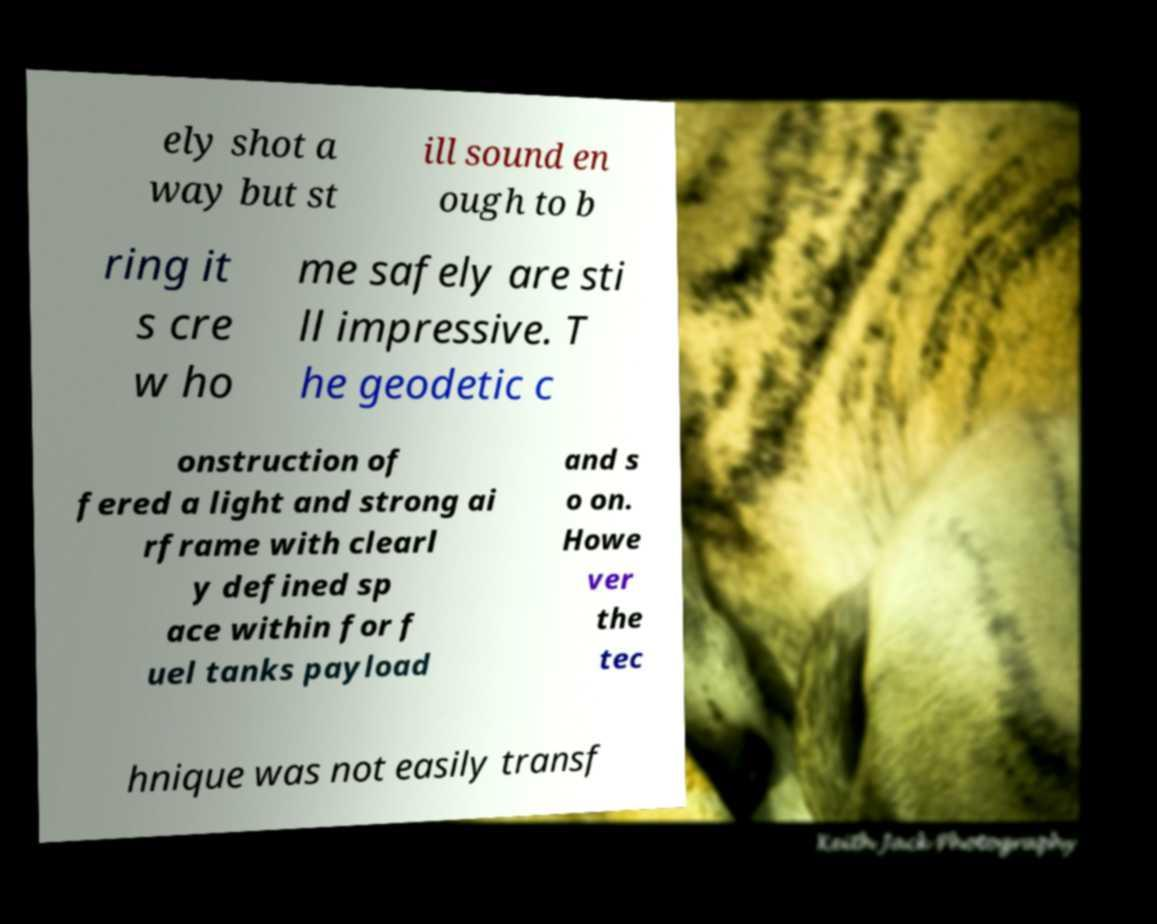For documentation purposes, I need the text within this image transcribed. Could you provide that? ely shot a way but st ill sound en ough to b ring it s cre w ho me safely are sti ll impressive. T he geodetic c onstruction of fered a light and strong ai rframe with clearl y defined sp ace within for f uel tanks payload and s o on. Howe ver the tec hnique was not easily transf 